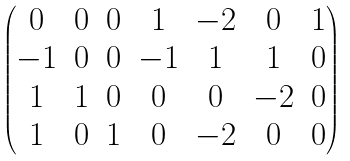Convert formula to latex. <formula><loc_0><loc_0><loc_500><loc_500>\begin{pmatrix} 0 & 0 & 0 & 1 & - 2 & 0 & 1 \\ - 1 & 0 & 0 & - 1 & 1 & 1 & 0 \\ 1 & 1 & 0 & 0 & 0 & - 2 & 0 \\ 1 & 0 & 1 & 0 & - 2 & 0 & 0 \end{pmatrix}</formula> 